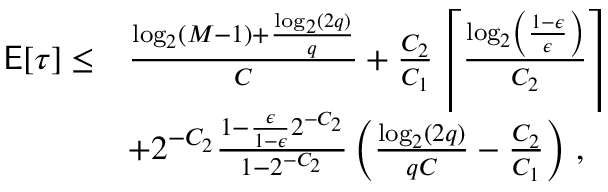<formula> <loc_0><loc_0><loc_500><loc_500>\begin{array} { r l } { E [ \tau ] \leq } & { \frac { \log _ { 2 } ( M - 1 ) + \frac { \log _ { 2 } ( 2 q ) } { q } } { C } + \frac { C _ { 2 } } { C _ { 1 } } \left \lceil \frac { \log _ { 2 } \left ( \frac { 1 - \epsilon } { \epsilon } \right ) } { C _ { 2 } } \right \rceil } \\ & { + 2 ^ { - C _ { 2 } } \frac { 1 - \frac { \epsilon } { 1 - \epsilon } 2 ^ { - C _ { 2 } } } { 1 - 2 ^ { - C _ { 2 } } } \left ( \frac { \log _ { 2 } ( 2 q ) } { q C } - \frac { C _ { 2 } } { C _ { 1 } } \right ) \, , } \end{array}</formula> 